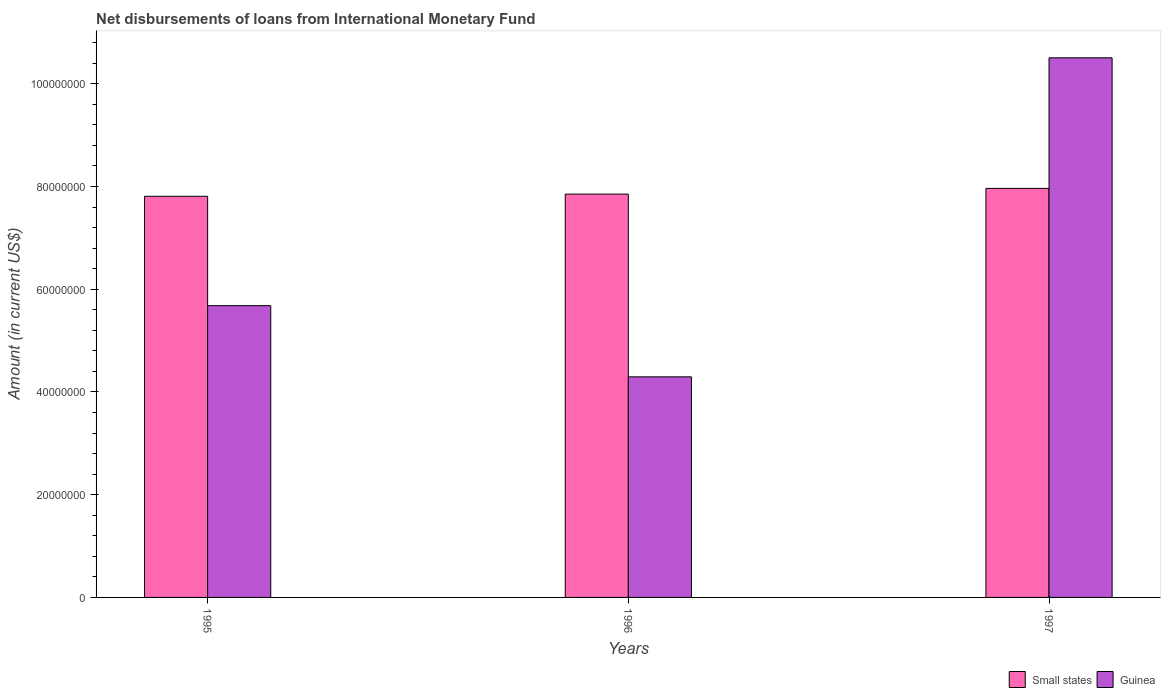How many different coloured bars are there?
Your answer should be very brief. 2. How many groups of bars are there?
Provide a succinct answer. 3. Are the number of bars per tick equal to the number of legend labels?
Provide a succinct answer. Yes. Are the number of bars on each tick of the X-axis equal?
Provide a succinct answer. Yes. What is the label of the 1st group of bars from the left?
Your answer should be very brief. 1995. What is the amount of loans disbursed in Guinea in 1997?
Make the answer very short. 1.05e+08. Across all years, what is the maximum amount of loans disbursed in Guinea?
Your answer should be very brief. 1.05e+08. Across all years, what is the minimum amount of loans disbursed in Guinea?
Your answer should be compact. 4.29e+07. What is the total amount of loans disbursed in Small states in the graph?
Your answer should be compact. 2.36e+08. What is the difference between the amount of loans disbursed in Guinea in 1996 and that in 1997?
Your answer should be very brief. -6.21e+07. What is the difference between the amount of loans disbursed in Small states in 1997 and the amount of loans disbursed in Guinea in 1995?
Your answer should be very brief. 2.28e+07. What is the average amount of loans disbursed in Guinea per year?
Offer a very short reply. 6.83e+07. In the year 1995, what is the difference between the amount of loans disbursed in Guinea and amount of loans disbursed in Small states?
Your answer should be very brief. -2.13e+07. What is the ratio of the amount of loans disbursed in Small states in 1995 to that in 1997?
Your answer should be very brief. 0.98. Is the amount of loans disbursed in Guinea in 1996 less than that in 1997?
Provide a short and direct response. Yes. Is the difference between the amount of loans disbursed in Guinea in 1995 and 1997 greater than the difference between the amount of loans disbursed in Small states in 1995 and 1997?
Provide a succinct answer. No. What is the difference between the highest and the second highest amount of loans disbursed in Guinea?
Make the answer very short. 4.83e+07. What is the difference between the highest and the lowest amount of loans disbursed in Guinea?
Provide a succinct answer. 6.21e+07. In how many years, is the amount of loans disbursed in Guinea greater than the average amount of loans disbursed in Guinea taken over all years?
Your answer should be compact. 1. Is the sum of the amount of loans disbursed in Guinea in 1996 and 1997 greater than the maximum amount of loans disbursed in Small states across all years?
Offer a terse response. Yes. What does the 2nd bar from the left in 1995 represents?
Your response must be concise. Guinea. What does the 1st bar from the right in 1995 represents?
Provide a short and direct response. Guinea. How many bars are there?
Keep it short and to the point. 6. Are all the bars in the graph horizontal?
Offer a terse response. No. How many years are there in the graph?
Give a very brief answer. 3. Are the values on the major ticks of Y-axis written in scientific E-notation?
Offer a very short reply. No. Does the graph contain any zero values?
Your answer should be compact. No. Where does the legend appear in the graph?
Your answer should be very brief. Bottom right. How are the legend labels stacked?
Your response must be concise. Horizontal. What is the title of the graph?
Make the answer very short. Net disbursements of loans from International Monetary Fund. Does "Ecuador" appear as one of the legend labels in the graph?
Offer a very short reply. No. What is the label or title of the Y-axis?
Your response must be concise. Amount (in current US$). What is the Amount (in current US$) in Small states in 1995?
Your answer should be compact. 7.81e+07. What is the Amount (in current US$) of Guinea in 1995?
Provide a short and direct response. 5.68e+07. What is the Amount (in current US$) of Small states in 1996?
Give a very brief answer. 7.85e+07. What is the Amount (in current US$) of Guinea in 1996?
Offer a terse response. 4.29e+07. What is the Amount (in current US$) of Small states in 1997?
Your answer should be compact. 7.96e+07. What is the Amount (in current US$) in Guinea in 1997?
Give a very brief answer. 1.05e+08. Across all years, what is the maximum Amount (in current US$) in Small states?
Make the answer very short. 7.96e+07. Across all years, what is the maximum Amount (in current US$) in Guinea?
Offer a very short reply. 1.05e+08. Across all years, what is the minimum Amount (in current US$) in Small states?
Give a very brief answer. 7.81e+07. Across all years, what is the minimum Amount (in current US$) of Guinea?
Provide a short and direct response. 4.29e+07. What is the total Amount (in current US$) of Small states in the graph?
Provide a succinct answer. 2.36e+08. What is the total Amount (in current US$) of Guinea in the graph?
Offer a terse response. 2.05e+08. What is the difference between the Amount (in current US$) in Small states in 1995 and that in 1996?
Your answer should be compact. -4.26e+05. What is the difference between the Amount (in current US$) of Guinea in 1995 and that in 1996?
Your answer should be compact. 1.39e+07. What is the difference between the Amount (in current US$) in Small states in 1995 and that in 1997?
Ensure brevity in your answer.  -1.54e+06. What is the difference between the Amount (in current US$) of Guinea in 1995 and that in 1997?
Your answer should be very brief. -4.83e+07. What is the difference between the Amount (in current US$) in Small states in 1996 and that in 1997?
Your response must be concise. -1.11e+06. What is the difference between the Amount (in current US$) in Guinea in 1996 and that in 1997?
Give a very brief answer. -6.21e+07. What is the difference between the Amount (in current US$) of Small states in 1995 and the Amount (in current US$) of Guinea in 1996?
Provide a succinct answer. 3.51e+07. What is the difference between the Amount (in current US$) in Small states in 1995 and the Amount (in current US$) in Guinea in 1997?
Ensure brevity in your answer.  -2.70e+07. What is the difference between the Amount (in current US$) of Small states in 1996 and the Amount (in current US$) of Guinea in 1997?
Your response must be concise. -2.65e+07. What is the average Amount (in current US$) in Small states per year?
Provide a short and direct response. 7.87e+07. What is the average Amount (in current US$) of Guinea per year?
Your response must be concise. 6.83e+07. In the year 1995, what is the difference between the Amount (in current US$) of Small states and Amount (in current US$) of Guinea?
Keep it short and to the point. 2.13e+07. In the year 1996, what is the difference between the Amount (in current US$) in Small states and Amount (in current US$) in Guinea?
Offer a very short reply. 3.56e+07. In the year 1997, what is the difference between the Amount (in current US$) in Small states and Amount (in current US$) in Guinea?
Provide a succinct answer. -2.54e+07. What is the ratio of the Amount (in current US$) in Small states in 1995 to that in 1996?
Ensure brevity in your answer.  0.99. What is the ratio of the Amount (in current US$) of Guinea in 1995 to that in 1996?
Your answer should be compact. 1.32. What is the ratio of the Amount (in current US$) in Small states in 1995 to that in 1997?
Provide a short and direct response. 0.98. What is the ratio of the Amount (in current US$) in Guinea in 1995 to that in 1997?
Your answer should be compact. 0.54. What is the ratio of the Amount (in current US$) in Small states in 1996 to that in 1997?
Your response must be concise. 0.99. What is the ratio of the Amount (in current US$) of Guinea in 1996 to that in 1997?
Provide a succinct answer. 0.41. What is the difference between the highest and the second highest Amount (in current US$) of Small states?
Make the answer very short. 1.11e+06. What is the difference between the highest and the second highest Amount (in current US$) of Guinea?
Ensure brevity in your answer.  4.83e+07. What is the difference between the highest and the lowest Amount (in current US$) of Small states?
Your answer should be compact. 1.54e+06. What is the difference between the highest and the lowest Amount (in current US$) of Guinea?
Keep it short and to the point. 6.21e+07. 